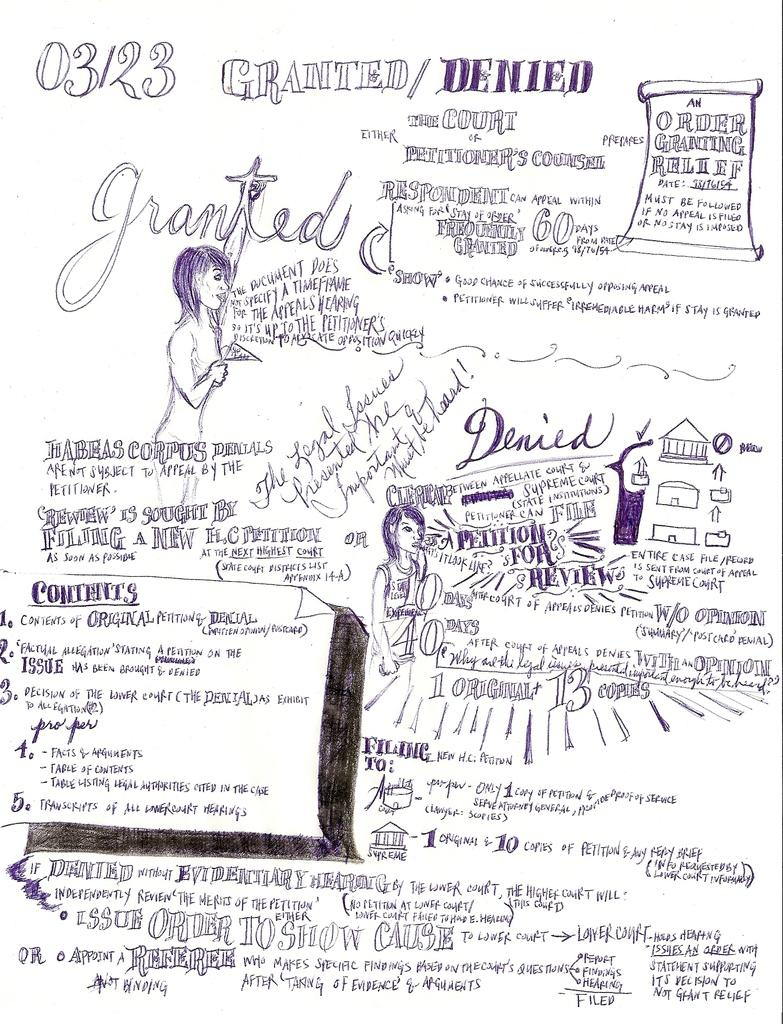What is present in the image that can be written on? There is a paper in the image that can be written on. What can be found on the paper in the image? There is text written on the paper in the image. What type of tax is being discussed in the text written on the paper? There is no mention of tax in the text written on the paper, as the provided facts only state that there is text present. 